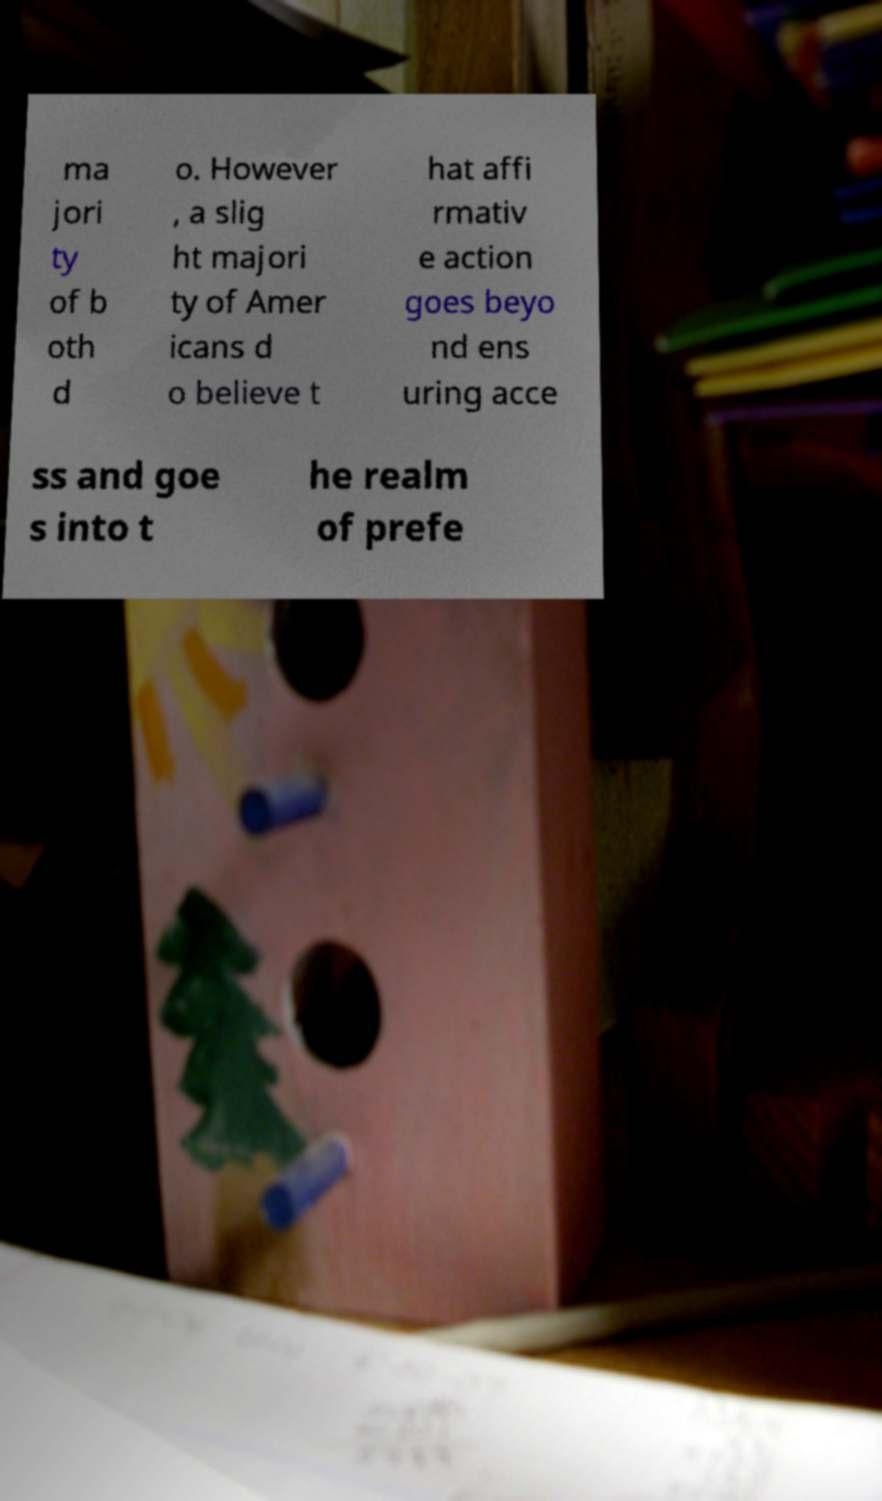Could you assist in decoding the text presented in this image and type it out clearly? ma jori ty of b oth d o. However , a slig ht majori ty of Amer icans d o believe t hat affi rmativ e action goes beyo nd ens uring acce ss and goe s into t he realm of prefe 